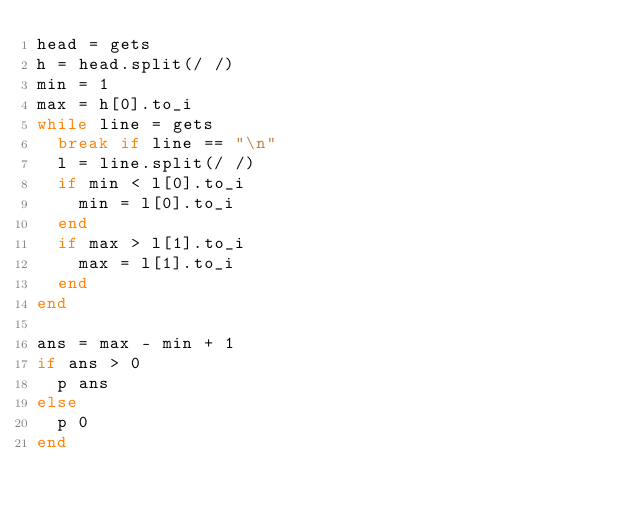Convert code to text. <code><loc_0><loc_0><loc_500><loc_500><_Ruby_>head = gets
h = head.split(/ /)
min = 1
max = h[0].to_i
while line = gets
  break if line == "\n"
  l = line.split(/ /)
  if min < l[0].to_i
    min = l[0].to_i
  end
  if max > l[1].to_i
    max = l[1].to_i
  end
end

ans = max - min + 1
if ans > 0
  p ans
else
  p 0
end</code> 